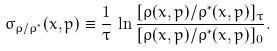<formula> <loc_0><loc_0><loc_500><loc_500>\sigma _ { \varrho / \varrho ^ { * } } ( x , p ) \equiv \frac { 1 } { \tau } \, \ln { \frac { [ \varrho ( x , p ) / \varrho ^ { * } ( x , p ) ] _ { \tau } } { [ \varrho ( x , p ) / \varrho ^ { * } ( x , p ) ] _ { 0 } } } .</formula> 